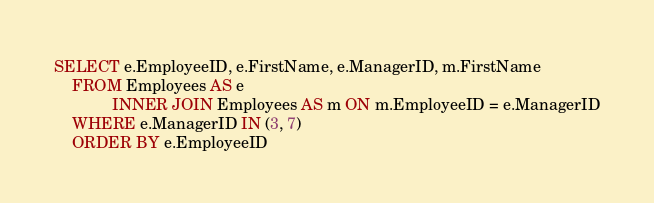Convert code to text. <code><loc_0><loc_0><loc_500><loc_500><_SQL_>SELECT e.EmployeeID, e.FirstName, e.ManagerID, m.FirstName
    FROM Employees AS e
             INNER JOIN Employees AS m ON m.EmployeeID = e.ManagerID
    WHERE e.ManagerID IN (3, 7)
    ORDER BY e.EmployeeID
</code> 